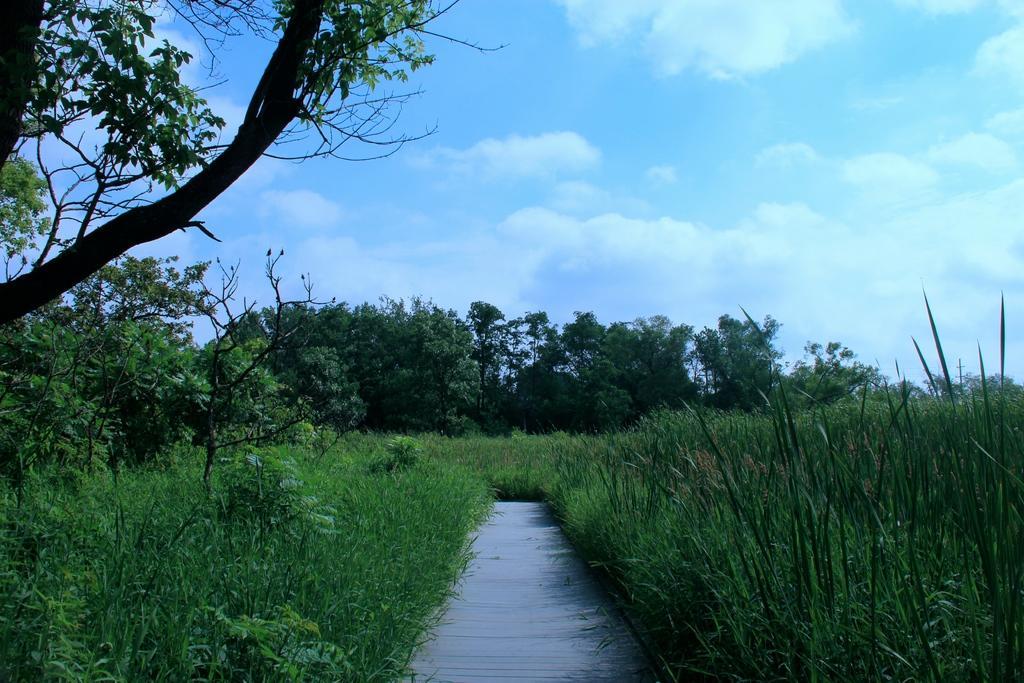Please provide a concise description of this image. In this picture there are trees. At the top there is sky and there are clouds. At the bottom there is grass. 